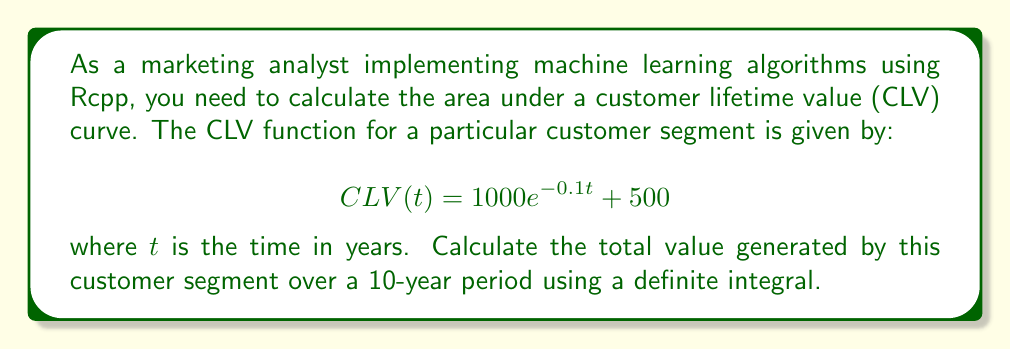Show me your answer to this math problem. To solve this problem, we need to calculate the definite integral of the CLV function over the interval [0, 10]. Here's a step-by-step approach:

1. Set up the definite integral:
   $$\int_0^{10} (1000e^{-0.1t} + 500) dt$$

2. Split the integral into two parts:
   $$\int_0^{10} 1000e^{-0.1t} dt + \int_0^{10} 500 dt$$

3. Solve the first part:
   $$1000 \int_0^{10} e^{-0.1t} dt$$
   Let $u = -0.1t$, then $du = -0.1 dt$ and $dt = -10 du$
   $$-10000 \int_0^{-1} e^u du = -10000 [e^u]_0^{-1} = -10000(e^{-1} - 1)$$

4. Solve the second part:
   $$500 \int_0^{10} dt = 500[t]_0^{10} = 5000$$

5. Combine the results:
   $$-10000(e^{-1} - 1) + 5000$$

6. Simplify:
   $$-10000e^{-1} + 10000 + 5000 = -10000/e + 15000$$

7. Calculate the final value:
   $$-3678.79 + 15000 = 11321.21$$
Answer: The total value generated by the customer segment over a 10-year period is approximately $11,321.21. 